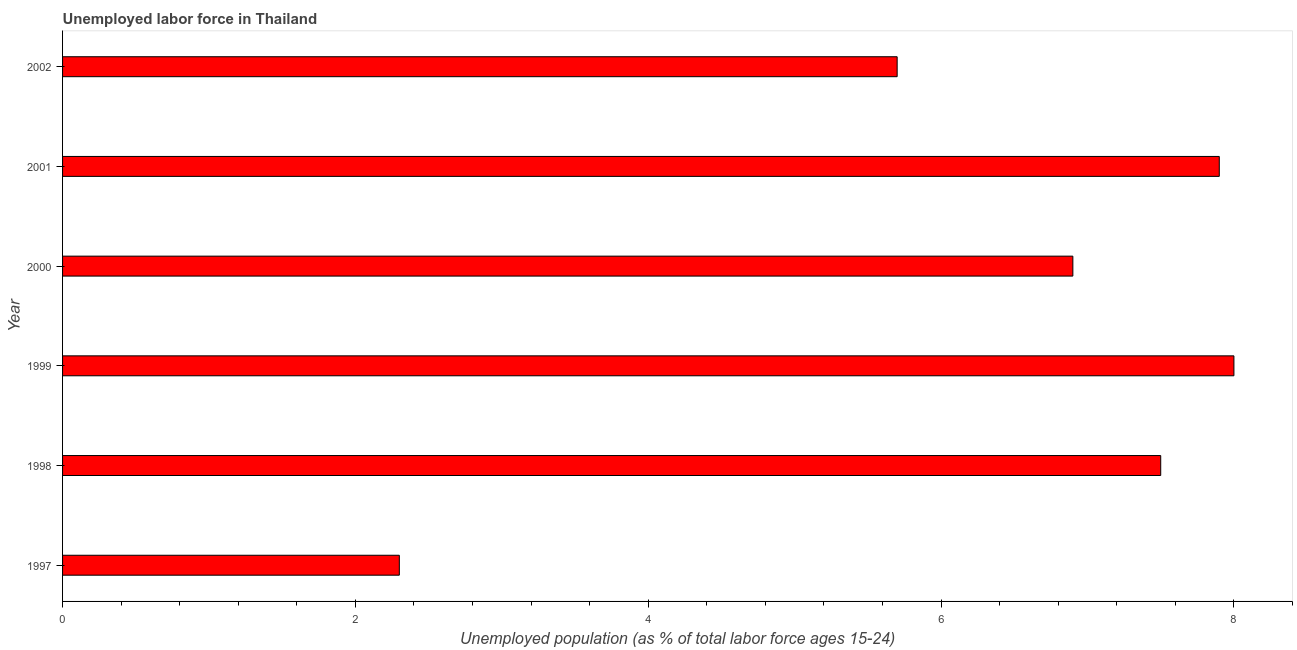Does the graph contain any zero values?
Your response must be concise. No. What is the title of the graph?
Make the answer very short. Unemployed labor force in Thailand. What is the label or title of the X-axis?
Provide a short and direct response. Unemployed population (as % of total labor force ages 15-24). What is the label or title of the Y-axis?
Keep it short and to the point. Year. Across all years, what is the minimum total unemployed youth population?
Provide a short and direct response. 2.3. In which year was the total unemployed youth population maximum?
Keep it short and to the point. 1999. What is the sum of the total unemployed youth population?
Give a very brief answer. 38.3. What is the average total unemployed youth population per year?
Ensure brevity in your answer.  6.38. What is the median total unemployed youth population?
Keep it short and to the point. 7.2. What is the ratio of the total unemployed youth population in 2000 to that in 2002?
Ensure brevity in your answer.  1.21. Is the total unemployed youth population in 2000 less than that in 2002?
Ensure brevity in your answer.  No. What is the difference between the highest and the second highest total unemployed youth population?
Give a very brief answer. 0.1. Is the sum of the total unemployed youth population in 1997 and 1998 greater than the maximum total unemployed youth population across all years?
Provide a succinct answer. Yes. How many bars are there?
Ensure brevity in your answer.  6. How many years are there in the graph?
Offer a terse response. 6. What is the difference between two consecutive major ticks on the X-axis?
Make the answer very short. 2. Are the values on the major ticks of X-axis written in scientific E-notation?
Offer a very short reply. No. What is the Unemployed population (as % of total labor force ages 15-24) of 1997?
Keep it short and to the point. 2.3. What is the Unemployed population (as % of total labor force ages 15-24) of 2000?
Make the answer very short. 6.9. What is the Unemployed population (as % of total labor force ages 15-24) in 2001?
Make the answer very short. 7.9. What is the Unemployed population (as % of total labor force ages 15-24) of 2002?
Give a very brief answer. 5.7. What is the difference between the Unemployed population (as % of total labor force ages 15-24) in 1997 and 2002?
Provide a succinct answer. -3.4. What is the difference between the Unemployed population (as % of total labor force ages 15-24) in 1998 and 1999?
Ensure brevity in your answer.  -0.5. What is the difference between the Unemployed population (as % of total labor force ages 15-24) in 1998 and 2002?
Provide a short and direct response. 1.8. What is the difference between the Unemployed population (as % of total labor force ages 15-24) in 1999 and 2002?
Ensure brevity in your answer.  2.3. What is the difference between the Unemployed population (as % of total labor force ages 15-24) in 2000 and 2002?
Make the answer very short. 1.2. What is the ratio of the Unemployed population (as % of total labor force ages 15-24) in 1997 to that in 1998?
Keep it short and to the point. 0.31. What is the ratio of the Unemployed population (as % of total labor force ages 15-24) in 1997 to that in 1999?
Provide a short and direct response. 0.29. What is the ratio of the Unemployed population (as % of total labor force ages 15-24) in 1997 to that in 2000?
Provide a short and direct response. 0.33. What is the ratio of the Unemployed population (as % of total labor force ages 15-24) in 1997 to that in 2001?
Provide a succinct answer. 0.29. What is the ratio of the Unemployed population (as % of total labor force ages 15-24) in 1997 to that in 2002?
Your answer should be compact. 0.4. What is the ratio of the Unemployed population (as % of total labor force ages 15-24) in 1998 to that in 1999?
Keep it short and to the point. 0.94. What is the ratio of the Unemployed population (as % of total labor force ages 15-24) in 1998 to that in 2000?
Your answer should be compact. 1.09. What is the ratio of the Unemployed population (as % of total labor force ages 15-24) in 1998 to that in 2001?
Keep it short and to the point. 0.95. What is the ratio of the Unemployed population (as % of total labor force ages 15-24) in 1998 to that in 2002?
Provide a short and direct response. 1.32. What is the ratio of the Unemployed population (as % of total labor force ages 15-24) in 1999 to that in 2000?
Keep it short and to the point. 1.16. What is the ratio of the Unemployed population (as % of total labor force ages 15-24) in 1999 to that in 2002?
Your answer should be compact. 1.4. What is the ratio of the Unemployed population (as % of total labor force ages 15-24) in 2000 to that in 2001?
Offer a very short reply. 0.87. What is the ratio of the Unemployed population (as % of total labor force ages 15-24) in 2000 to that in 2002?
Your answer should be very brief. 1.21. What is the ratio of the Unemployed population (as % of total labor force ages 15-24) in 2001 to that in 2002?
Your answer should be very brief. 1.39. 